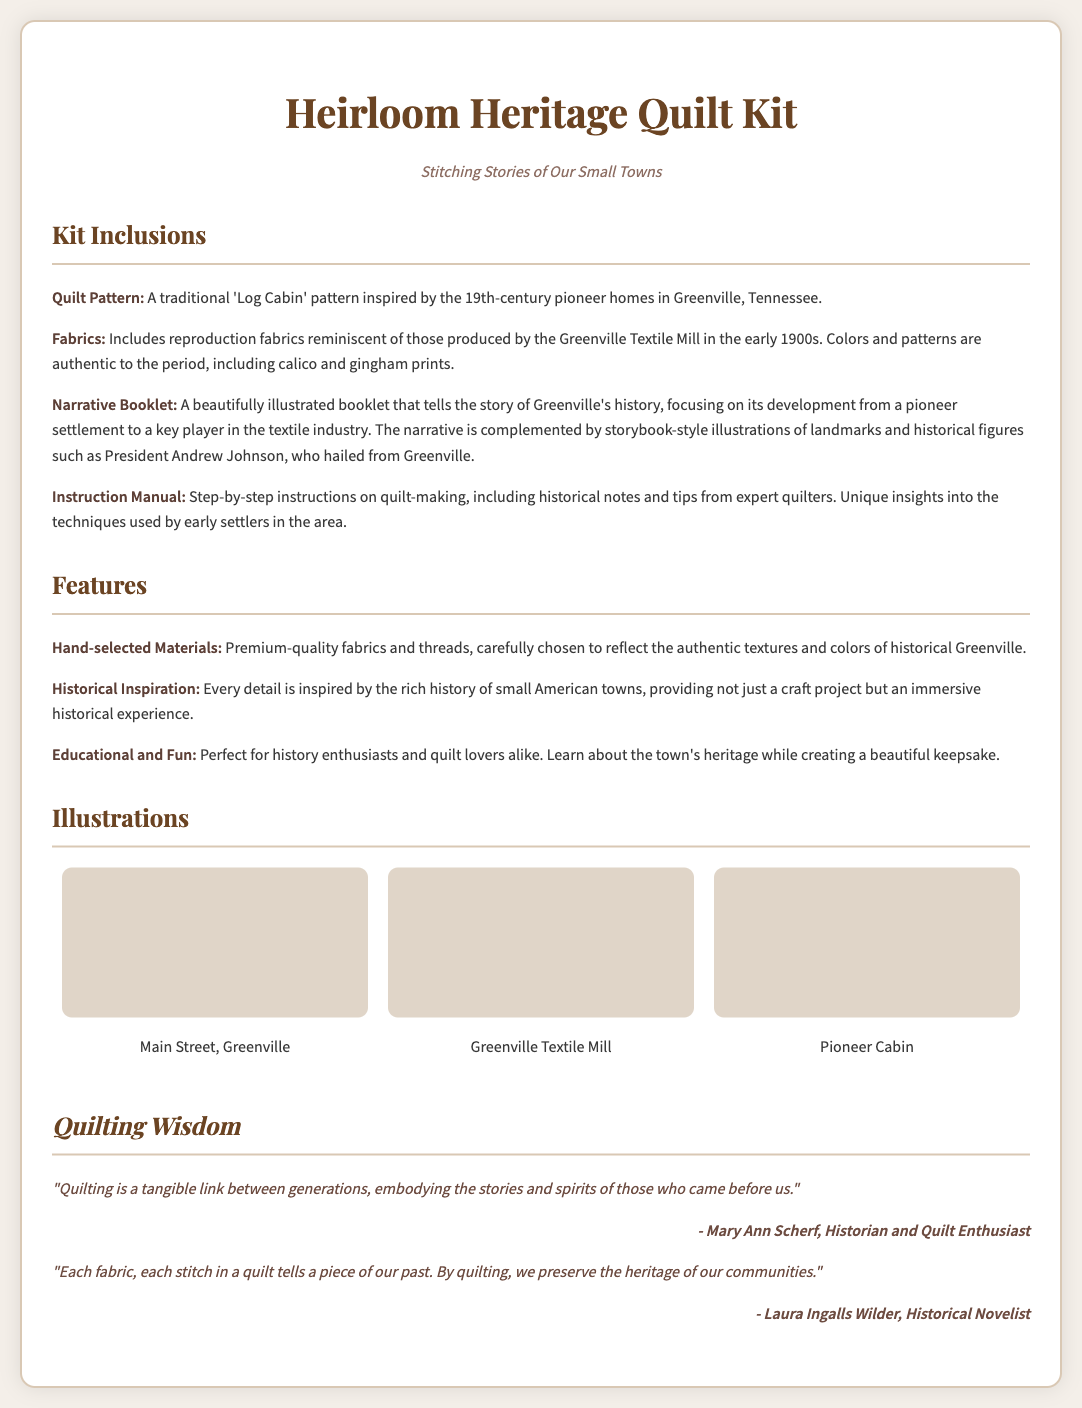What is the name of the quilt pattern included in the kit? The quilt pattern included in the kit is a traditional 'Log Cabin' pattern inspired by the 19th-century pioneer homes in Greenville, Tennessee.
Answer: Log Cabin What types of fabrics are included in the kit? The kit includes reproduction fabrics reminiscent of those produced by the Greenville Textile Mill in the early 1900s, including calico and gingham prints.
Answer: Calico and gingham prints What historical figure is mentioned in the narrative booklet? The narrative booklet mentions President Andrew Johnson, who hailed from Greenville.
Answer: Andrew Johnson What is the primary theme of the Heirloom Heritage Quilt Kit? The primary theme of the quilt kit is to provide a craft project that connects the act of quilt-making with the history of small American towns.
Answer: History of small American towns How many illustrations are included in the illustrations section? The illustrations section displays a total of three illustrations related to Greenville.
Answer: Three What kind of instructions does the instruction manual provide? The instruction manual provides step-by-step instructions on quilt-making, including historical notes and tips from expert quilters.
Answer: Step-by-step instructions What is the tagline of the quilt kit? The tagline of the quilt kit is "Stitching Stories of Our Small Towns."
Answer: Stitching Stories of Our Small Towns What is the purpose of the Narrative Booklet? The purpose of the Narrative Booklet is to tell the story of Greenville's history, focusing on its development from a pioneer settlement to a key player in the textile industry.
Answer: Tell the story of Greenville's history 